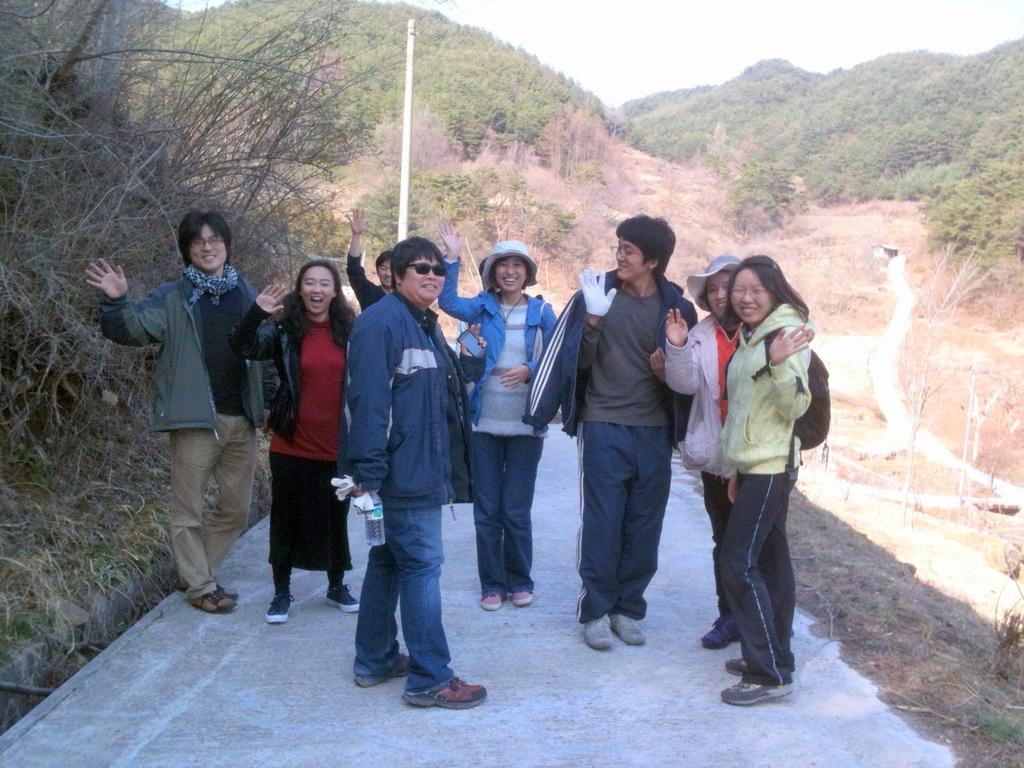Can you describe this image briefly? In this picture i can see group of people are standing together on the road and smiling. The person in the middle is holding a bottle. In the background i can see grass, trees and sky. 